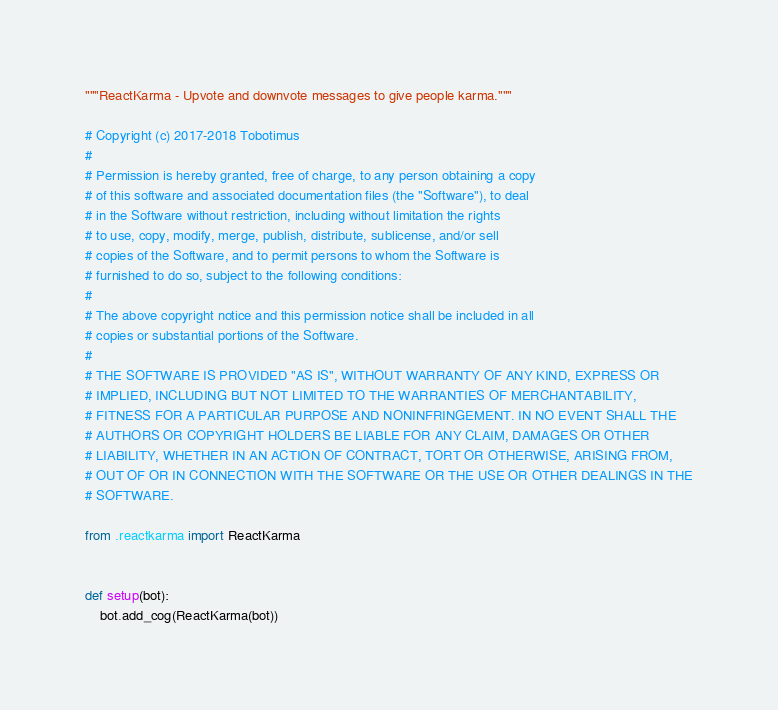<code> <loc_0><loc_0><loc_500><loc_500><_Python_>"""ReactKarma - Upvote and downvote messages to give people karma."""

# Copyright (c) 2017-2018 Tobotimus
#
# Permission is hereby granted, free of charge, to any person obtaining a copy
# of this software and associated documentation files (the "Software"), to deal
# in the Software without restriction, including without limitation the rights
# to use, copy, modify, merge, publish, distribute, sublicense, and/or sell
# copies of the Software, and to permit persons to whom the Software is
# furnished to do so, subject to the following conditions:
#
# The above copyright notice and this permission notice shall be included in all
# copies or substantial portions of the Software.
#
# THE SOFTWARE IS PROVIDED "AS IS", WITHOUT WARRANTY OF ANY KIND, EXPRESS OR
# IMPLIED, INCLUDING BUT NOT LIMITED TO THE WARRANTIES OF MERCHANTABILITY,
# FITNESS FOR A PARTICULAR PURPOSE AND NONINFRINGEMENT. IN NO EVENT SHALL THE
# AUTHORS OR COPYRIGHT HOLDERS BE LIABLE FOR ANY CLAIM, DAMAGES OR OTHER
# LIABILITY, WHETHER IN AN ACTION OF CONTRACT, TORT OR OTHERWISE, ARISING FROM,
# OUT OF OR IN CONNECTION WITH THE SOFTWARE OR THE USE OR OTHER DEALINGS IN THE
# SOFTWARE.

from .reactkarma import ReactKarma


def setup(bot):
    bot.add_cog(ReactKarma(bot))
</code> 